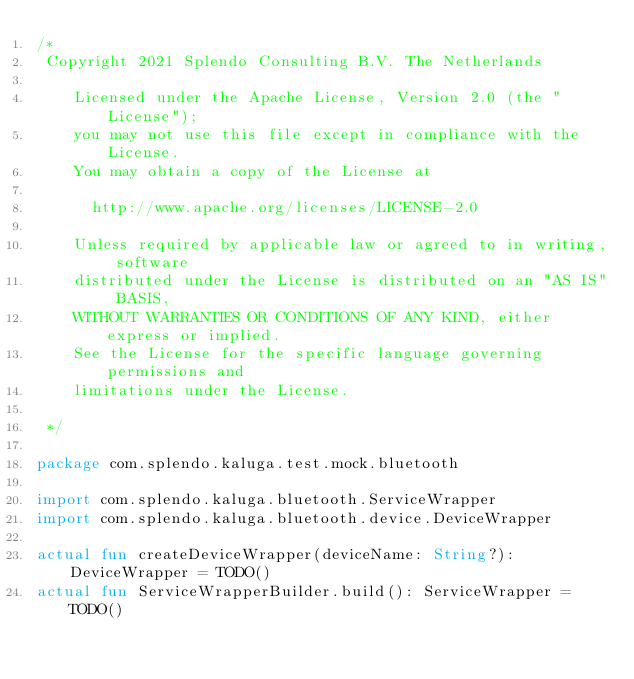Convert code to text. <code><loc_0><loc_0><loc_500><loc_500><_Kotlin_>/*
 Copyright 2021 Splendo Consulting B.V. The Netherlands

    Licensed under the Apache License, Version 2.0 (the "License");
    you may not use this file except in compliance with the License.
    You may obtain a copy of the License at

      http://www.apache.org/licenses/LICENSE-2.0

    Unless required by applicable law or agreed to in writing, software
    distributed under the License is distributed on an "AS IS" BASIS,
    WITHOUT WARRANTIES OR CONDITIONS OF ANY KIND, either express or implied.
    See the License for the specific language governing permissions and
    limitations under the License.

 */

package com.splendo.kaluga.test.mock.bluetooth

import com.splendo.kaluga.bluetooth.ServiceWrapper
import com.splendo.kaluga.bluetooth.device.DeviceWrapper

actual fun createDeviceWrapper(deviceName: String?): DeviceWrapper = TODO()
actual fun ServiceWrapperBuilder.build(): ServiceWrapper = TODO()
</code> 